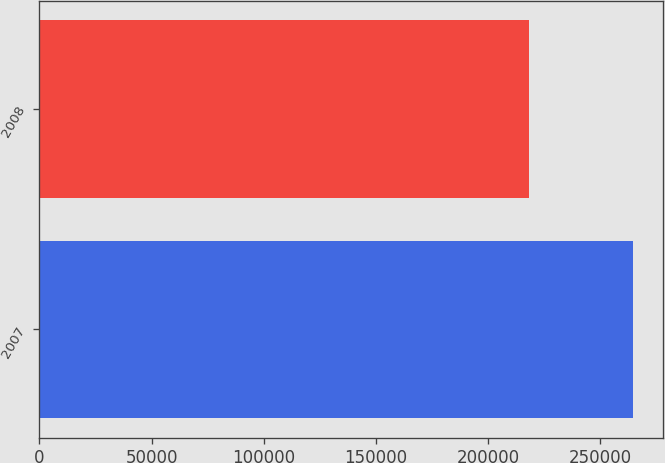Convert chart. <chart><loc_0><loc_0><loc_500><loc_500><bar_chart><fcel>2007<fcel>2008<nl><fcel>264701<fcel>218167<nl></chart> 